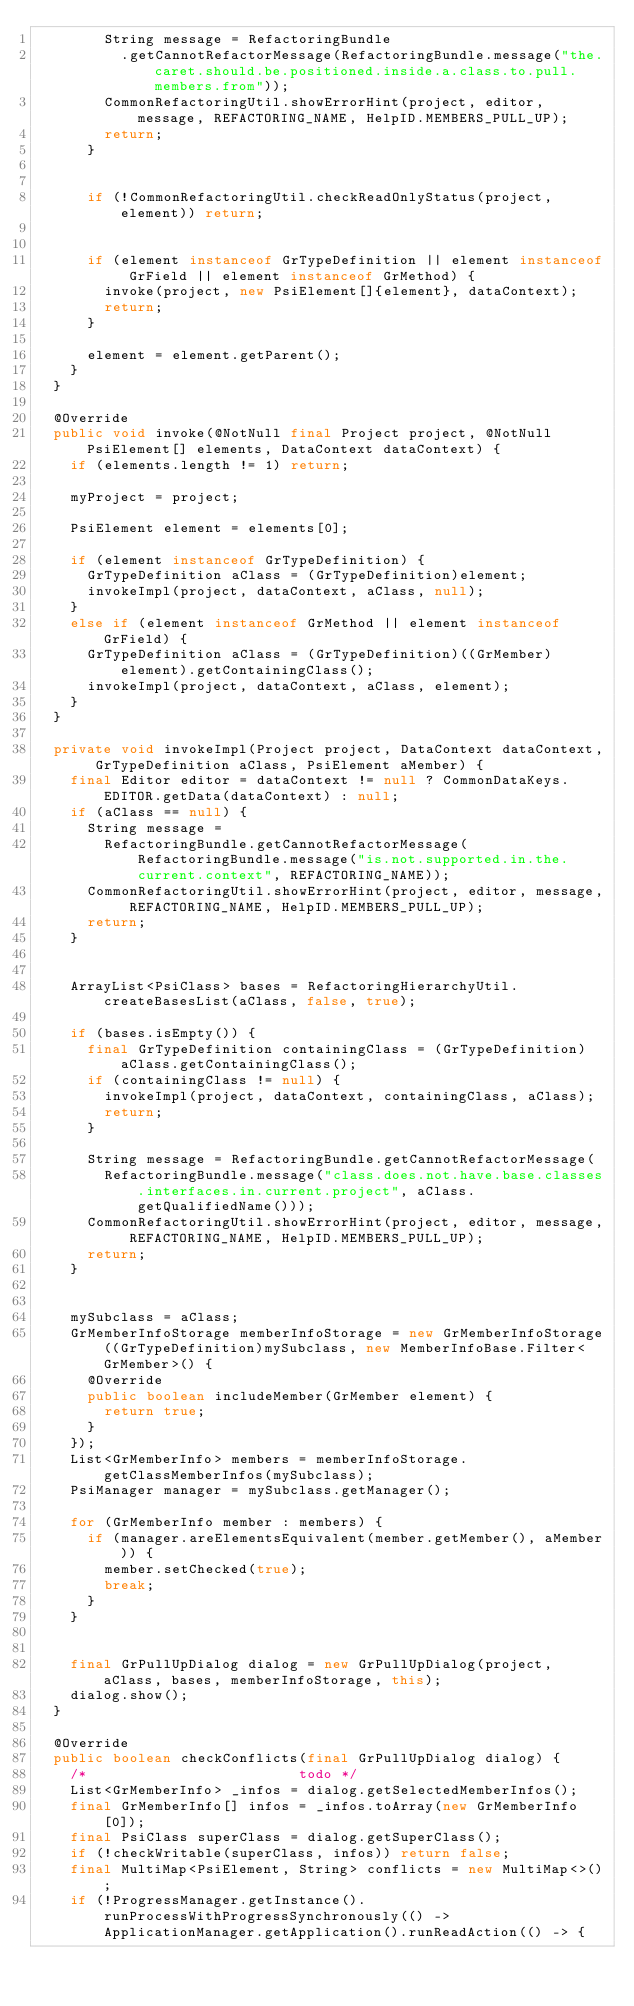Convert code to text. <code><loc_0><loc_0><loc_500><loc_500><_Java_>        String message = RefactoringBundle
          .getCannotRefactorMessage(RefactoringBundle.message("the.caret.should.be.positioned.inside.a.class.to.pull.members.from"));
        CommonRefactoringUtil.showErrorHint(project, editor, message, REFACTORING_NAME, HelpID.MEMBERS_PULL_UP);
        return;
      }


      if (!CommonRefactoringUtil.checkReadOnlyStatus(project, element)) return;


      if (element instanceof GrTypeDefinition || element instanceof GrField || element instanceof GrMethod) {
        invoke(project, new PsiElement[]{element}, dataContext);
        return;
      }

      element = element.getParent();
    }
  }

  @Override
  public void invoke(@NotNull final Project project, @NotNull PsiElement[] elements, DataContext dataContext) {
    if (elements.length != 1) return;

    myProject = project;

    PsiElement element = elements[0];

    if (element instanceof GrTypeDefinition) {
      GrTypeDefinition aClass = (GrTypeDefinition)element;
      invokeImpl(project, dataContext, aClass, null);
    }
    else if (element instanceof GrMethod || element instanceof GrField) {
      GrTypeDefinition aClass = (GrTypeDefinition)((GrMember)element).getContainingClass();
      invokeImpl(project, dataContext, aClass, element);
    }
  }

  private void invokeImpl(Project project, DataContext dataContext, GrTypeDefinition aClass, PsiElement aMember) {
    final Editor editor = dataContext != null ? CommonDataKeys.EDITOR.getData(dataContext) : null;
    if (aClass == null) {
      String message =
        RefactoringBundle.getCannotRefactorMessage(RefactoringBundle.message("is.not.supported.in.the.current.context", REFACTORING_NAME));
      CommonRefactoringUtil.showErrorHint(project, editor, message, REFACTORING_NAME, HelpID.MEMBERS_PULL_UP);
      return;
    }


    ArrayList<PsiClass> bases = RefactoringHierarchyUtil.createBasesList(aClass, false, true);

    if (bases.isEmpty()) {
      final GrTypeDefinition containingClass = (GrTypeDefinition)aClass.getContainingClass();
      if (containingClass != null) {
        invokeImpl(project, dataContext, containingClass, aClass);
        return;
      }

      String message = RefactoringBundle.getCannotRefactorMessage(
        RefactoringBundle.message("class.does.not.have.base.classes.interfaces.in.current.project", aClass.getQualifiedName()));
      CommonRefactoringUtil.showErrorHint(project, editor, message, REFACTORING_NAME, HelpID.MEMBERS_PULL_UP);
      return;
    }


    mySubclass = aClass;
    GrMemberInfoStorage memberInfoStorage = new GrMemberInfoStorage((GrTypeDefinition)mySubclass, new MemberInfoBase.Filter<GrMember>() {
      @Override
      public boolean includeMember(GrMember element) {
        return true;
      }
    });
    List<GrMemberInfo> members = memberInfoStorage.getClassMemberInfos(mySubclass);
    PsiManager manager = mySubclass.getManager();

    for (GrMemberInfo member : members) {
      if (manager.areElementsEquivalent(member.getMember(), aMember)) {
        member.setChecked(true);
        break;
      }
    }


    final GrPullUpDialog dialog = new GrPullUpDialog(project, aClass, bases, memberInfoStorage, this);
    dialog.show();
  }

  @Override
  public boolean checkConflicts(final GrPullUpDialog dialog) {
    /*                         todo */
    List<GrMemberInfo> _infos = dialog.getSelectedMemberInfos();
    final GrMemberInfo[] infos = _infos.toArray(new GrMemberInfo[0]);
    final PsiClass superClass = dialog.getSuperClass();
    if (!checkWritable(superClass, infos)) return false;
    final MultiMap<PsiElement, String> conflicts = new MultiMap<>();
    if (!ProgressManager.getInstance().runProcessWithProgressSynchronously(() -> ApplicationManager.getApplication().runReadAction(() -> {</code> 